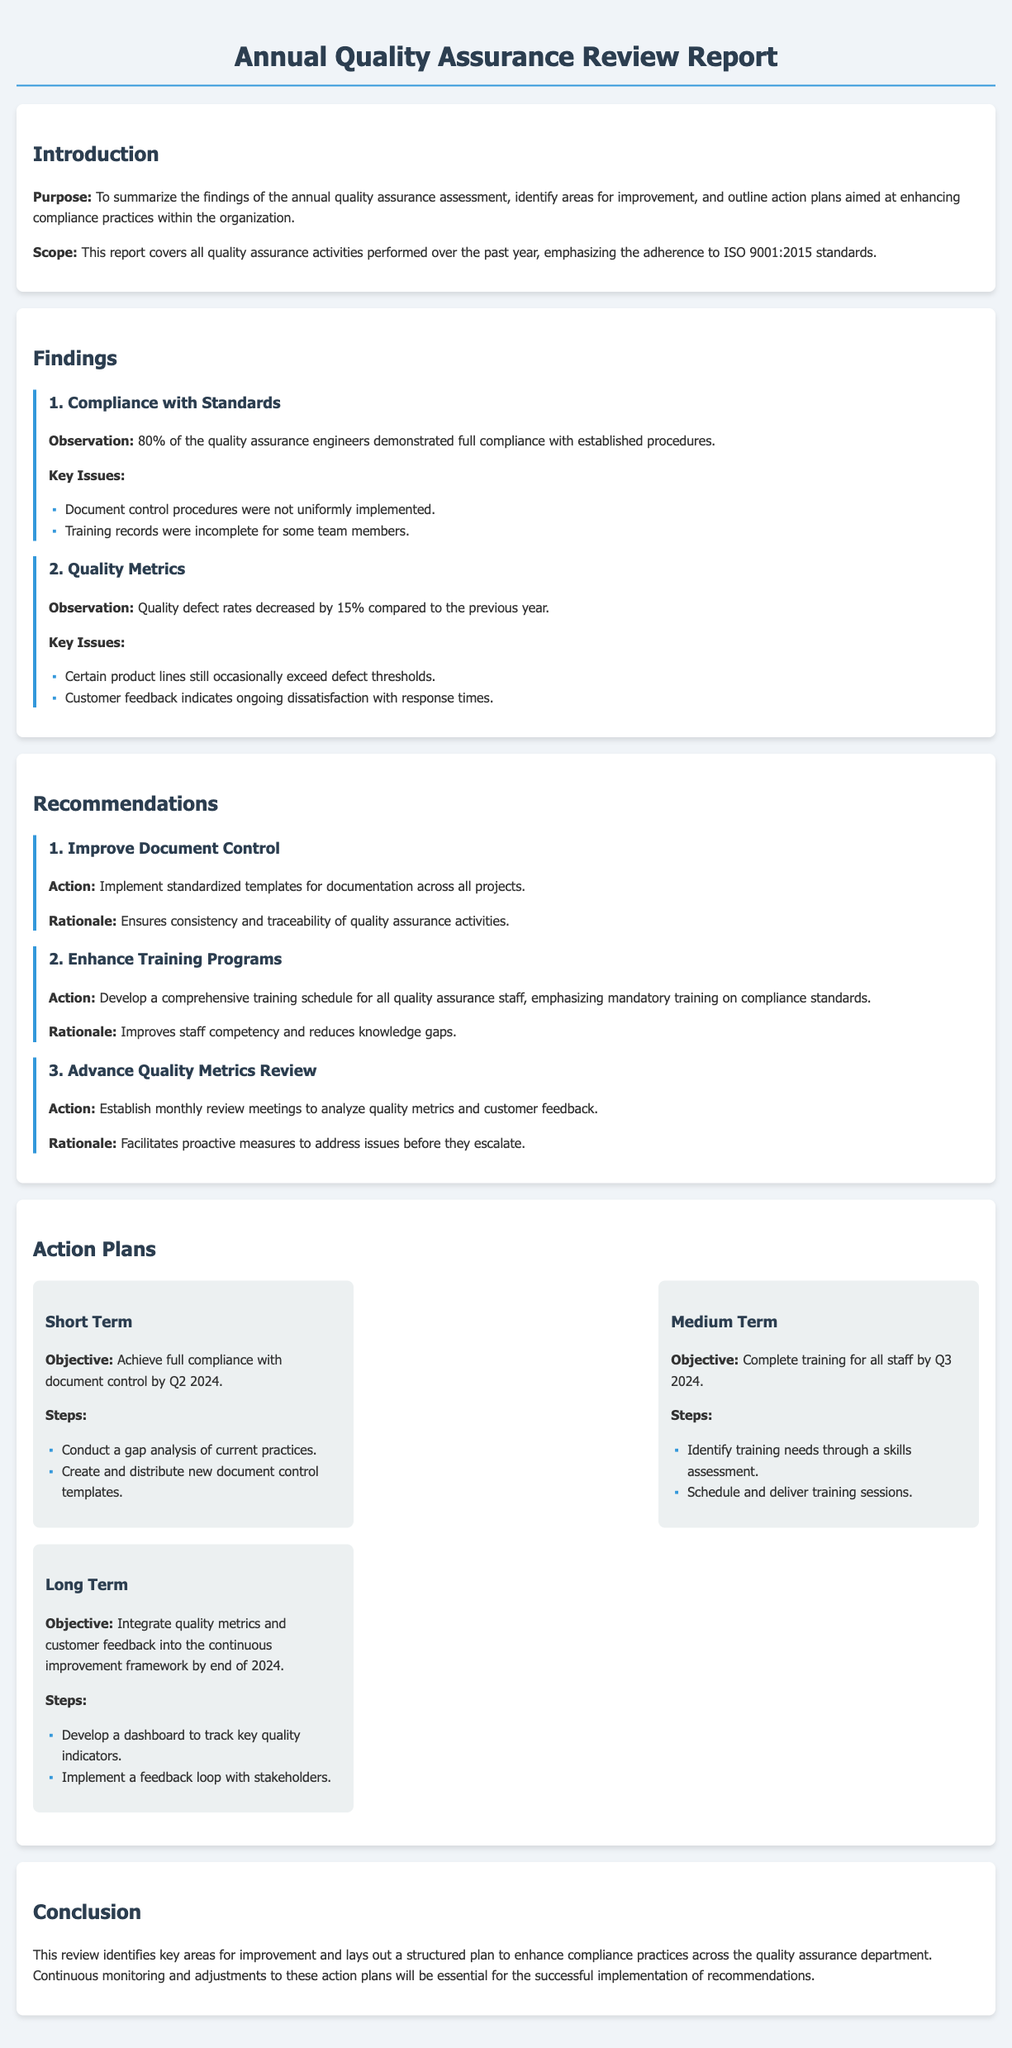What is the purpose of the report? The purpose is to summarize the findings of the annual quality assurance assessment, identify areas for improvement, and outline action plans aimed at enhancing compliance practices.
Answer: To summarize findings and outline action plans What percentage of quality assurance engineers demonstrated full compliance? The document states that 80% of the quality assurance engineers demonstrated full compliance with established procedures.
Answer: 80% What key issue was noted regarding document control? The key issue noted is that document control procedures were not uniformly implemented.
Answer: Not uniformly implemented What action is recommended to improve document control? The recommendation is to implement standardized templates for documentation across all projects.
Answer: Implement standardized templates By when is the short-term objective for document control compliance expected to be achieved? The report indicates that full compliance with document control is to be achieved by Q2 2024.
Answer: Q2 2024 What is the objective of the medium-term action plan? The medium-term objective is to complete training for all staff by Q3 2024.
Answer: Complete training by Q3 2024 Why is enhancing training programs recommended? It is recommended to improve staff competency and reduce knowledge gaps.
Answer: Improves staff competency What key metrics are to be reviewed monthly according to the recommendations? The key metrics to be reviewed monthly are quality metrics and customer feedback.
Answer: Quality metrics and customer feedback 